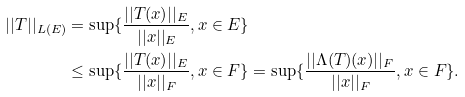<formula> <loc_0><loc_0><loc_500><loc_500>| | T | | _ { L ( E ) } & = \sup \{ \frac { | | T ( x ) | | _ { E } } { | | x | | _ { E } } , x \in E \} \\ & \leq \sup \{ \frac { | | T ( x ) | | _ { E } } { | | x | | _ { F } } , x \in F \} = \sup \{ \frac { | | \Lambda ( T ) ( x ) | | _ { F } } { | | x | | _ { F } } , x \in F \} .</formula> 